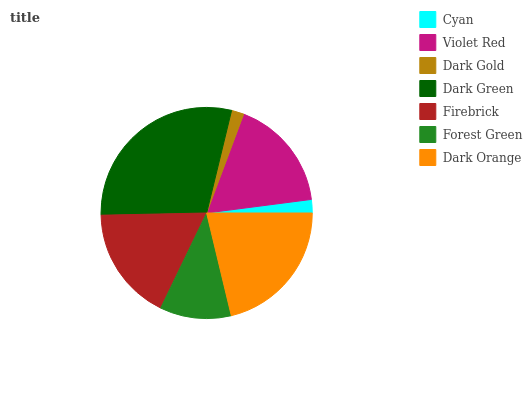Is Dark Gold the minimum?
Answer yes or no. Yes. Is Dark Green the maximum?
Answer yes or no. Yes. Is Violet Red the minimum?
Answer yes or no. No. Is Violet Red the maximum?
Answer yes or no. No. Is Violet Red greater than Cyan?
Answer yes or no. Yes. Is Cyan less than Violet Red?
Answer yes or no. Yes. Is Cyan greater than Violet Red?
Answer yes or no. No. Is Violet Red less than Cyan?
Answer yes or no. No. Is Violet Red the high median?
Answer yes or no. Yes. Is Violet Red the low median?
Answer yes or no. Yes. Is Dark Gold the high median?
Answer yes or no. No. Is Dark Orange the low median?
Answer yes or no. No. 